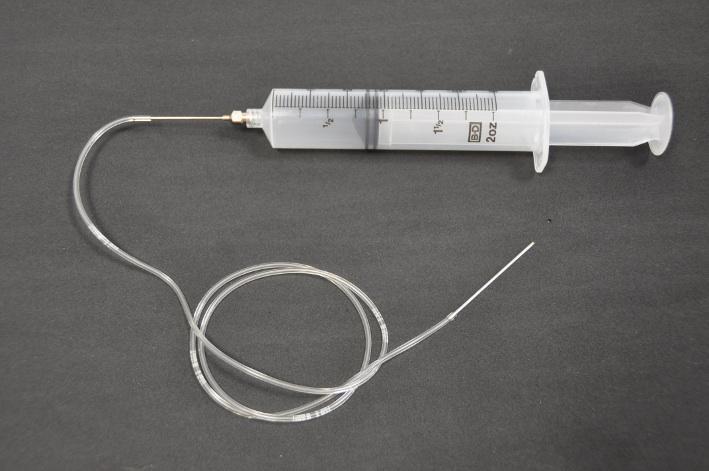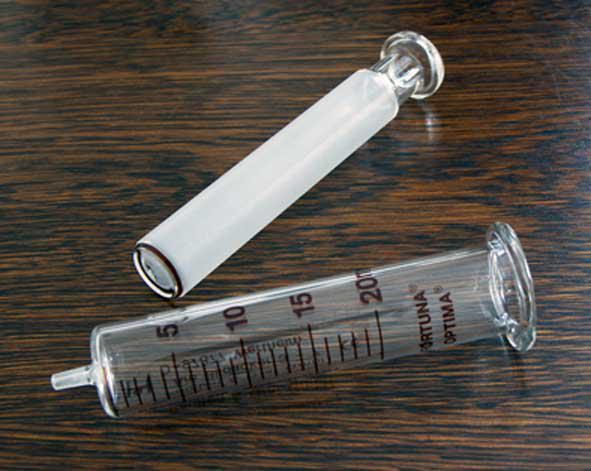The first image is the image on the left, the second image is the image on the right. For the images displayed, is the sentence "There is a white wire attached to all of the syringes in one of the images, and no wires in the other image." factually correct? Answer yes or no. Yes. 